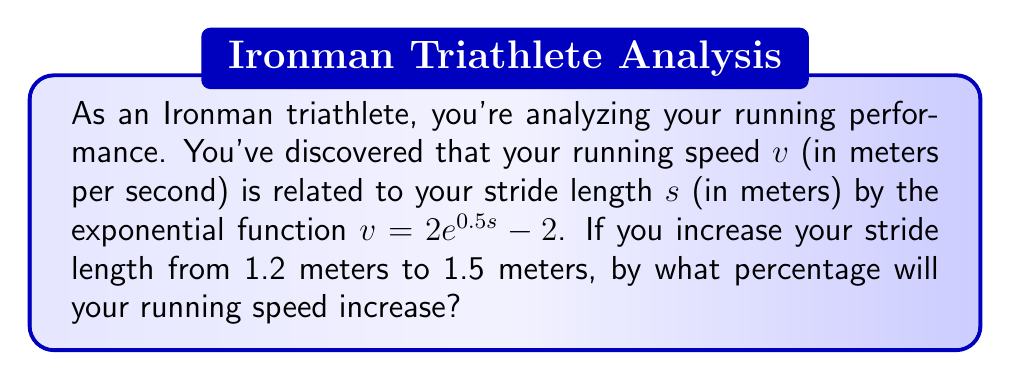Teach me how to tackle this problem. Let's approach this step-by-step:

1) We're given the function $v = 2e^{0.5s} - 2$, where $v$ is speed and $s$ is stride length.

2) We need to calculate the speed at two stride lengths:
   $s_1 = 1.2$ meters and $s_2 = 1.5$ meters

3) For $s_1 = 1.2$:
   $v_1 = 2e^{0.5(1.2)} - 2$
   $v_1 = 2e^{0.6} - 2$
   $v_1 = 2(1.8221) - 2 = 1.6442$ m/s

4) For $s_2 = 1.5$:
   $v_2 = 2e^{0.5(1.5)} - 2$
   $v_2 = 2e^{0.75} - 2$
   $v_2 = 2(2.1170) - 2 = 2.2340$ m/s

5) To calculate the percentage increase:
   Percentage increase = $\frac{\text{Increase}}{\text{Original}} \times 100\%$
   $= \frac{v_2 - v_1}{v_1} \times 100\%$
   $= \frac{2.2340 - 1.6442}{1.6442} \times 100\%$
   $= 0.3587 \times 100\% = 35.87\%$

Therefore, increasing your stride length from 1.2 meters to 1.5 meters will increase your running speed by approximately 35.87%.
Answer: 35.87% 